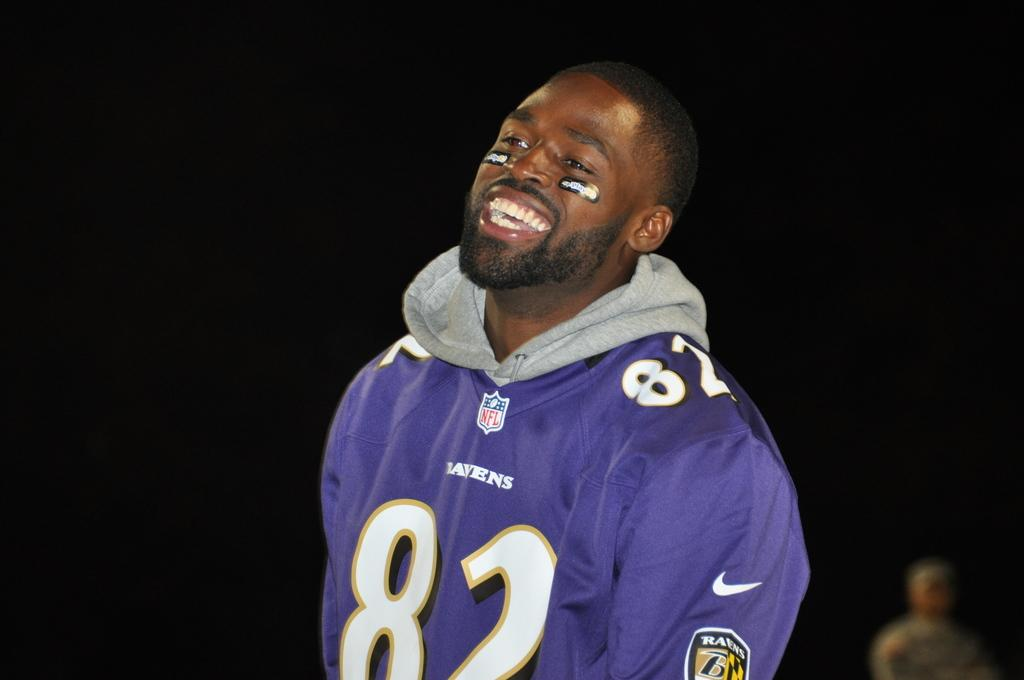<image>
Share a concise interpretation of the image provided. A man wear a jersey with the NFL logo on it. 